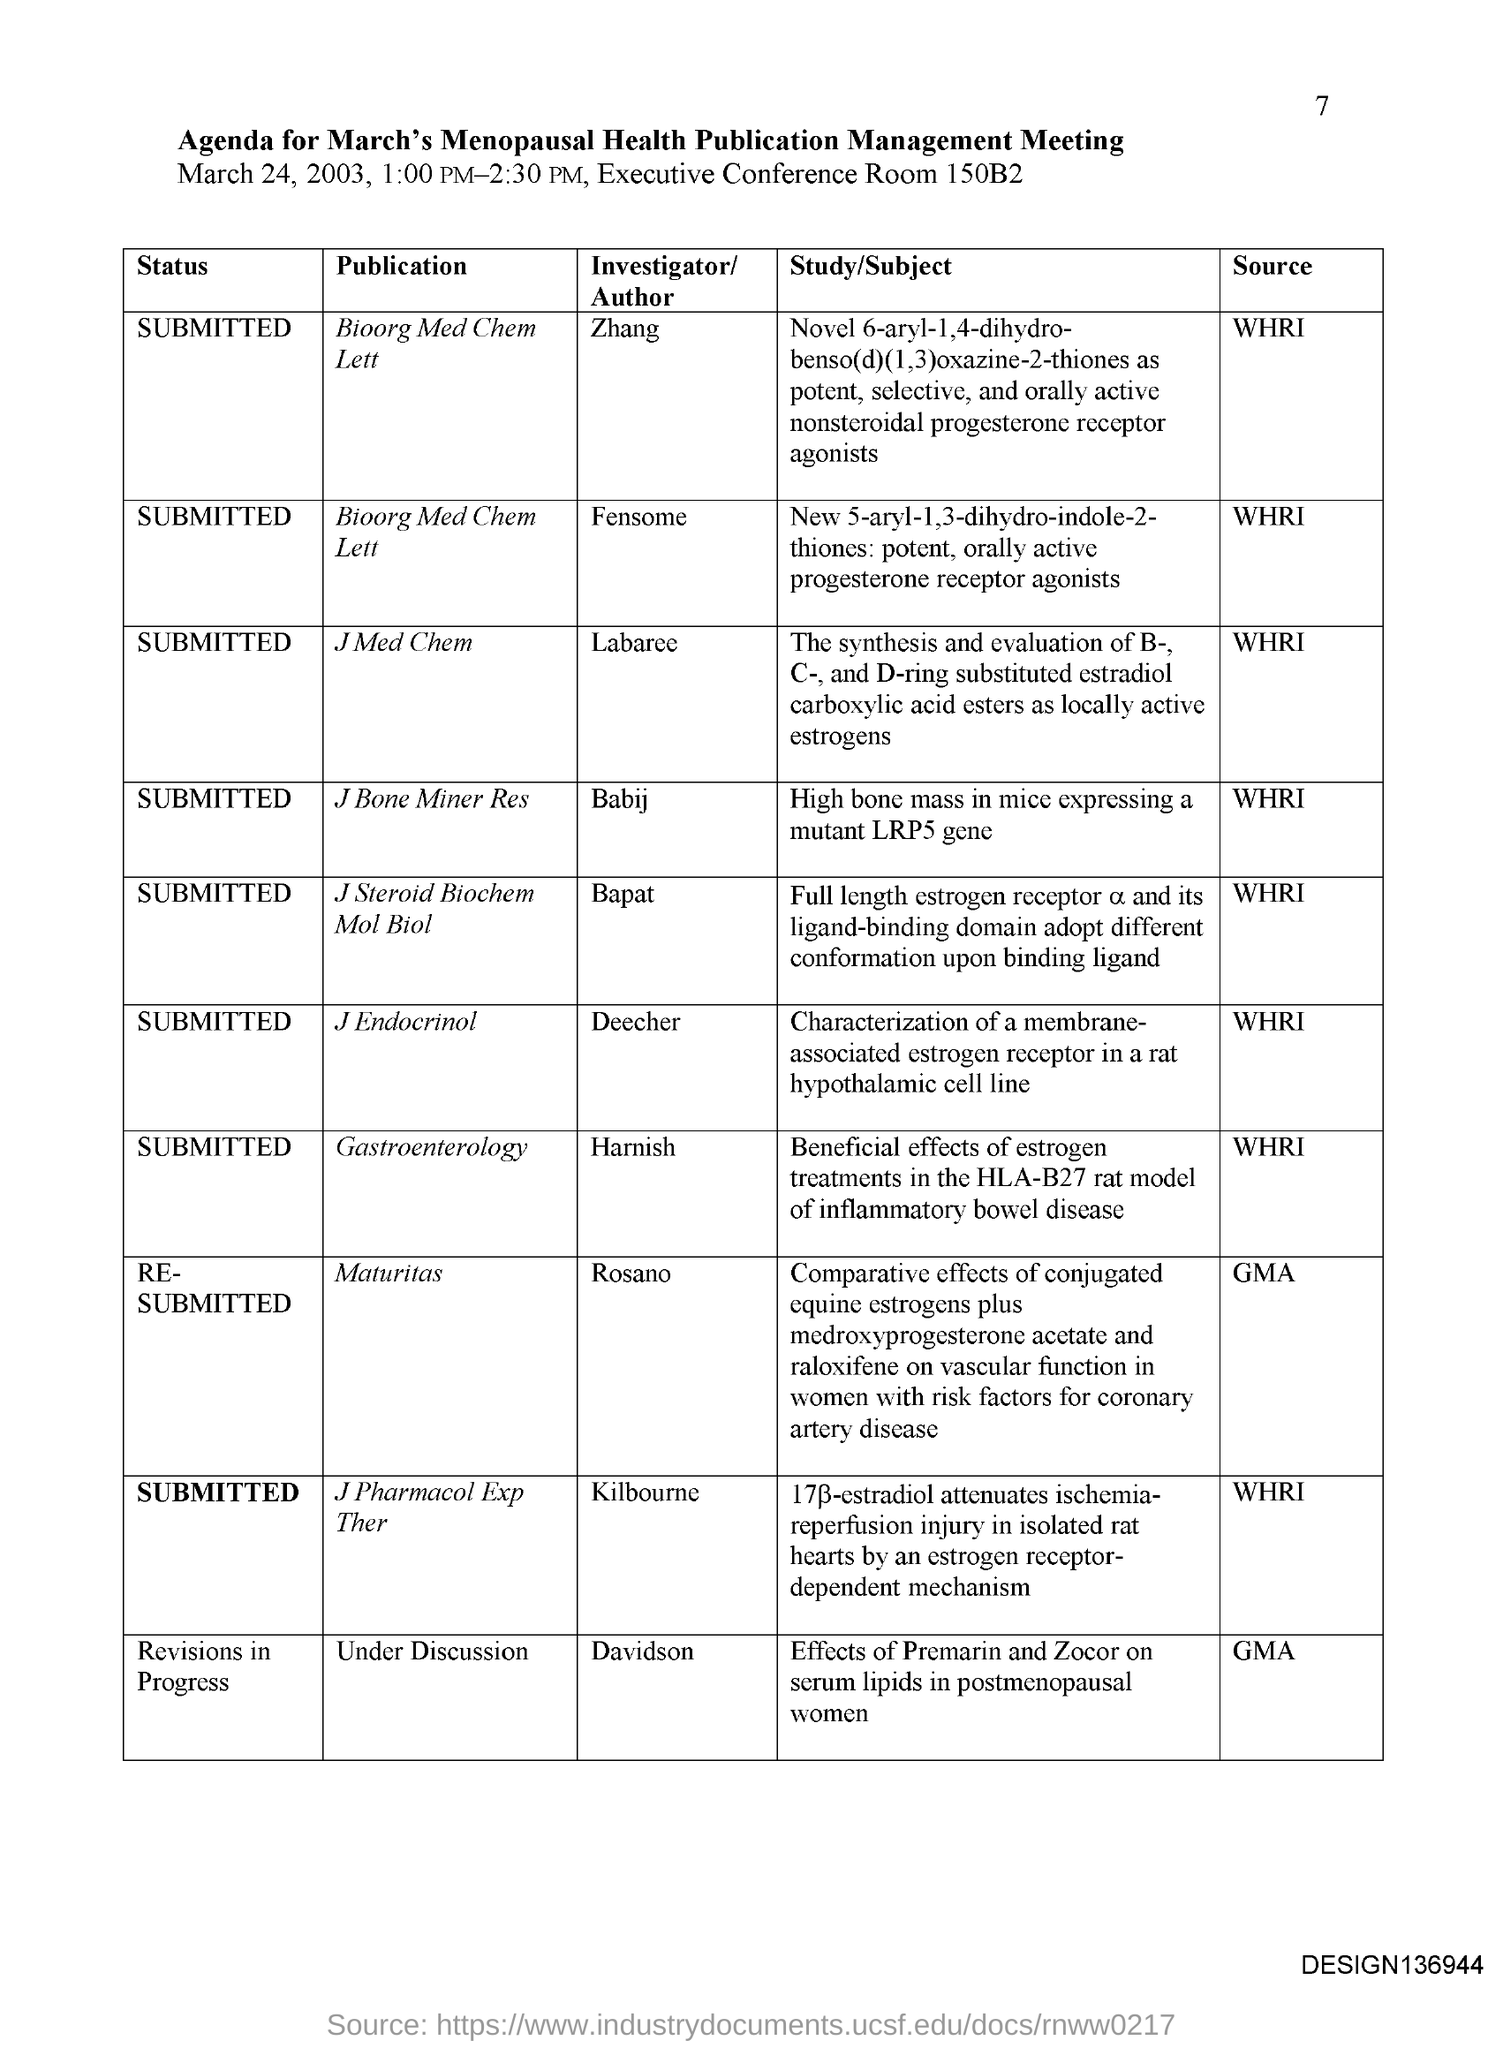Can you provide more details about the study related to high bone mass in mice on the agenda? Certainly! The study referenced in the agenda under 'J Bone Miner Res' by Babij investigates high bone mass in mice expressing a mutant LRP5 gene. This research is likely exploring the genetic factors that affect bone density and could have implications for understanding conditions like osteoporosis. 